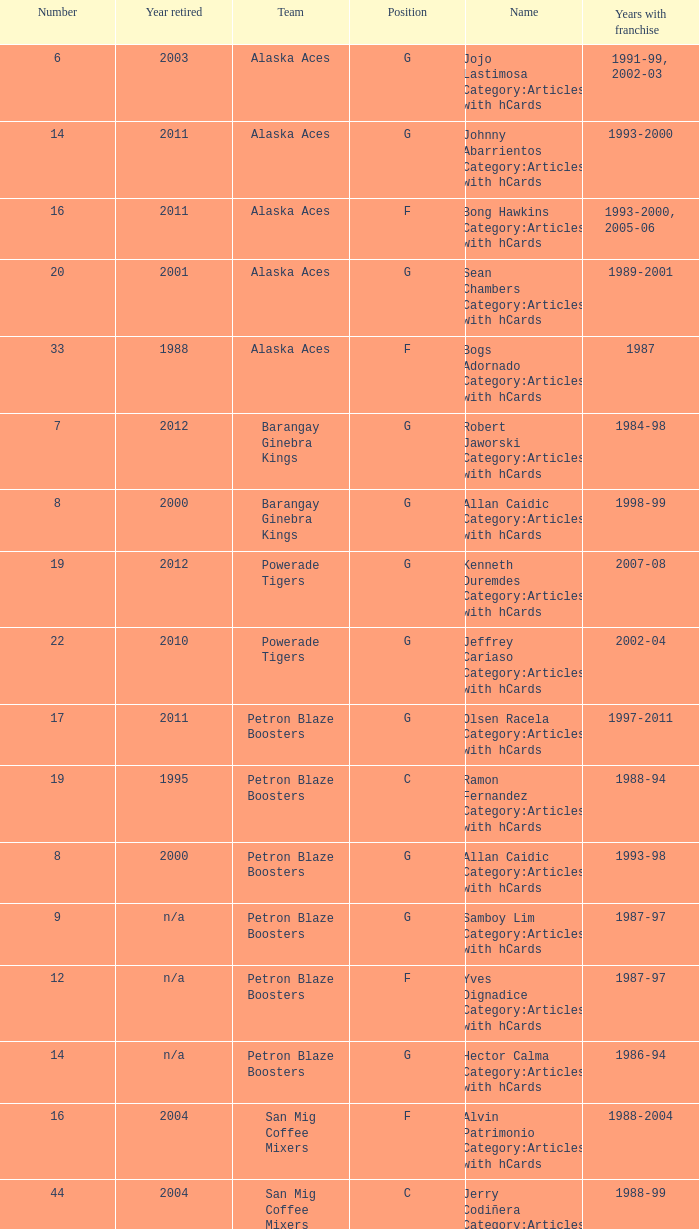How many years did the team in slot number 9 have a franchise? 1987-97. 